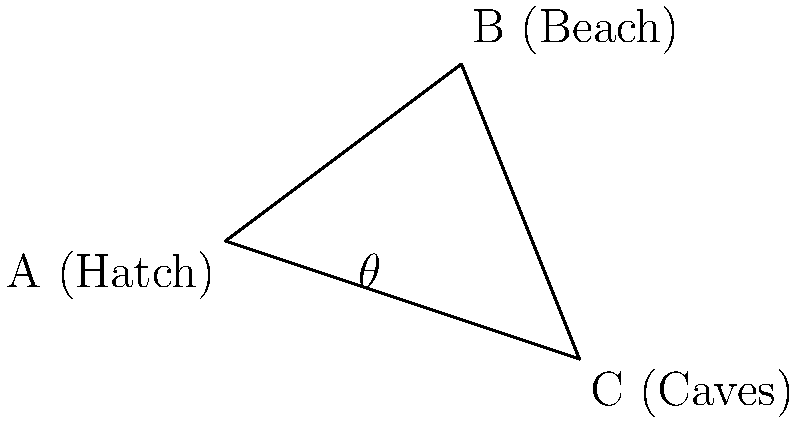In the island from "Lost", Evangeline Lilly's character Kate needs to travel from the Hatch (point A) to the Beach (point B) and then to the Caves (point C). If the angle between the path from the Hatch to the Beach and the path from the Hatch to the Caves is $\theta$, what is the value of $\cos \theta$? To find $\cos \theta$, we can use the dot product formula for vectors. Let's approach this step-by-step:

1) First, we need to find the vectors $\vec{AB}$ and $\vec{AC}$:
   $\vec{AB} = B - A = (4,3) - (0,0) = (4,3)$
   $\vec{AC} = C - A = (6,-2) - (0,0) = (6,-2)$

2) The dot product formula states that:
   $\cos \theta = \frac{\vec{AB} \cdot \vec{AC}}{|\vec{AB}||\vec{AC}|}$

3) Let's calculate the dot product $\vec{AB} \cdot \vec{AC}$:
   $\vec{AB} \cdot \vec{AC} = (4)(6) + (3)(-2) = 24 - 6 = 18$

4) Now we need to calculate the magnitudes of the vectors:
   $|\vec{AB}| = \sqrt{4^2 + 3^2} = \sqrt{25} = 5$
   $|\vec{AC}| = \sqrt{6^2 + (-2)^2} = \sqrt{40} = 2\sqrt{10}$

5) Putting it all together:
   $\cos \theta = \frac{18}{5(2\sqrt{10})} = \frac{18}{10\sqrt{10}} = \frac{9}{5\sqrt{10}}$

Therefore, the value of $\cos \theta$ is $\frac{9}{5\sqrt{10}}$.
Answer: $\frac{9}{5\sqrt{10}}$ 